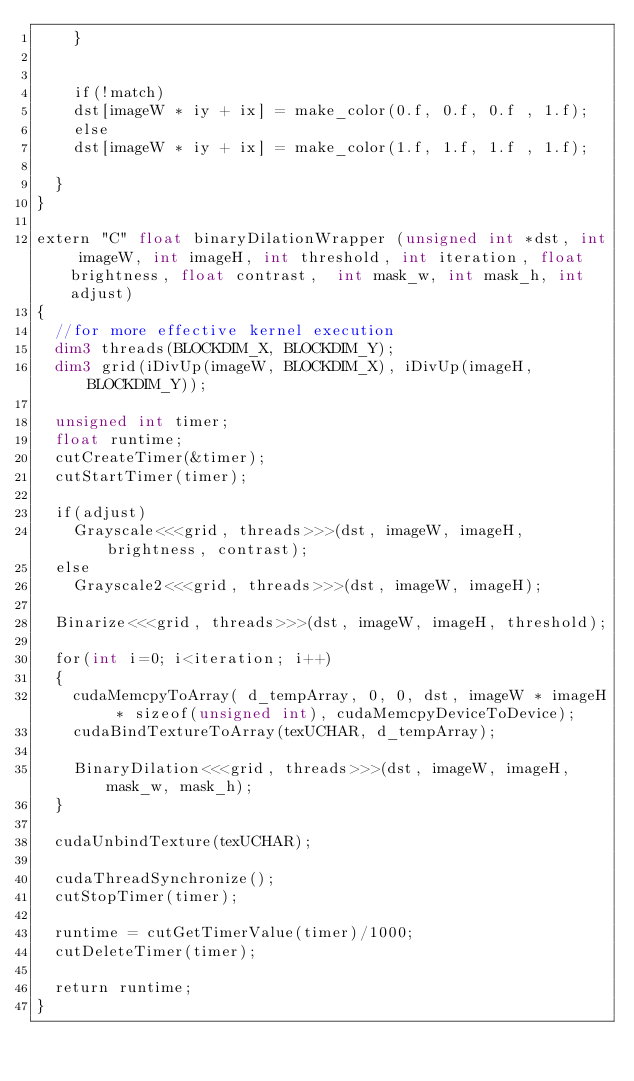<code> <loc_0><loc_0><loc_500><loc_500><_Cuda_>		}
		  

		if(!match)
		dst[imageW * iy + ix] = make_color(0.f, 0.f, 0.f , 1.f);
		else
		dst[imageW * iy + ix] = make_color(1.f, 1.f, 1.f , 1.f);
	
	}
}

extern "C" float binaryDilationWrapper (unsigned int *dst, int imageW, int imageH, int threshold, int iteration, float brightness, float contrast,  int mask_w, int mask_h, int adjust)
{
	//for more effective kernel execution
	dim3 threads(BLOCKDIM_X, BLOCKDIM_Y);
	dim3 grid(iDivUp(imageW, BLOCKDIM_X), iDivUp(imageH, BLOCKDIM_Y));

	unsigned int timer;
	float runtime;
	cutCreateTimer(&timer);
	cutStartTimer(timer);
	
	if(adjust)
		Grayscale<<<grid, threads>>>(dst, imageW, imageH, brightness, contrast);
	else
		Grayscale2<<<grid, threads>>>(dst, imageW, imageH);

	Binarize<<<grid, threads>>>(dst, imageW, imageH, threshold);

	for(int i=0; i<iteration; i++)
	{
		cudaMemcpyToArray( d_tempArray, 0, 0, dst, imageW * imageH * sizeof(unsigned int), cudaMemcpyDeviceToDevice);
		cudaBindTextureToArray(texUCHAR, d_tempArray);

		BinaryDilation<<<grid, threads>>>(dst, imageW, imageH,  mask_w, mask_h);
	}

	cudaUnbindTexture(texUCHAR);

	cudaThreadSynchronize();
	cutStopTimer(timer);
	
	runtime = cutGetTimerValue(timer)/1000;
	cutDeleteTimer(timer);
	
	return runtime;
}</code> 